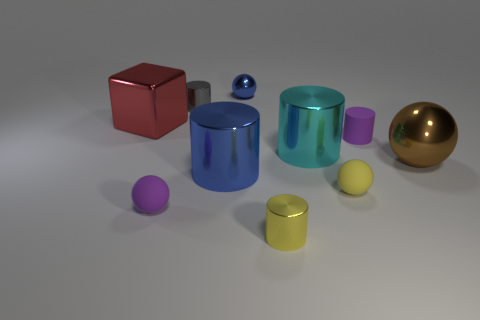Subtract all rubber cylinders. How many cylinders are left? 4 Subtract 2 cylinders. How many cylinders are left? 3 Subtract all yellow cylinders. How many cylinders are left? 4 Subtract all red cylinders. Subtract all purple cubes. How many cylinders are left? 5 Subtract all spheres. How many objects are left? 6 Add 8 yellow matte balls. How many yellow matte balls are left? 9 Add 5 large cyan metal things. How many large cyan metal things exist? 6 Subtract 1 yellow cylinders. How many objects are left? 9 Subtract all small gray objects. Subtract all big brown metal spheres. How many objects are left? 8 